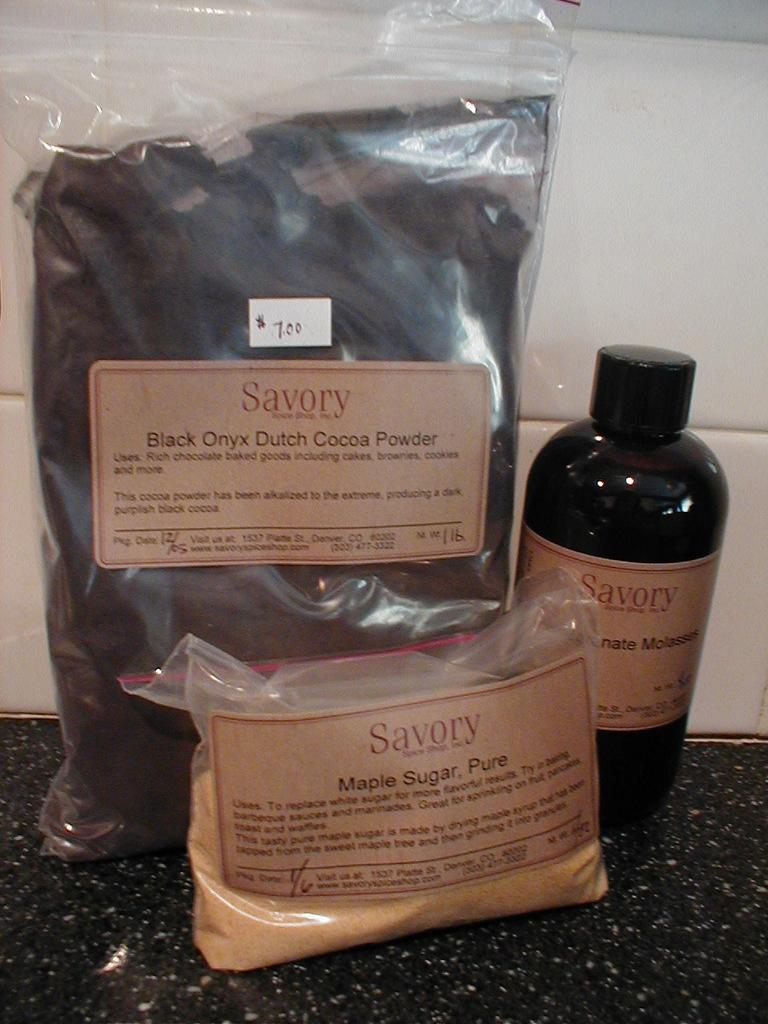<image>
Relay a brief, clear account of the picture shown. Savory brand items include Black Onyx Dutch Cocoa Powder, Pure Maple Sugar, and Molasses. 